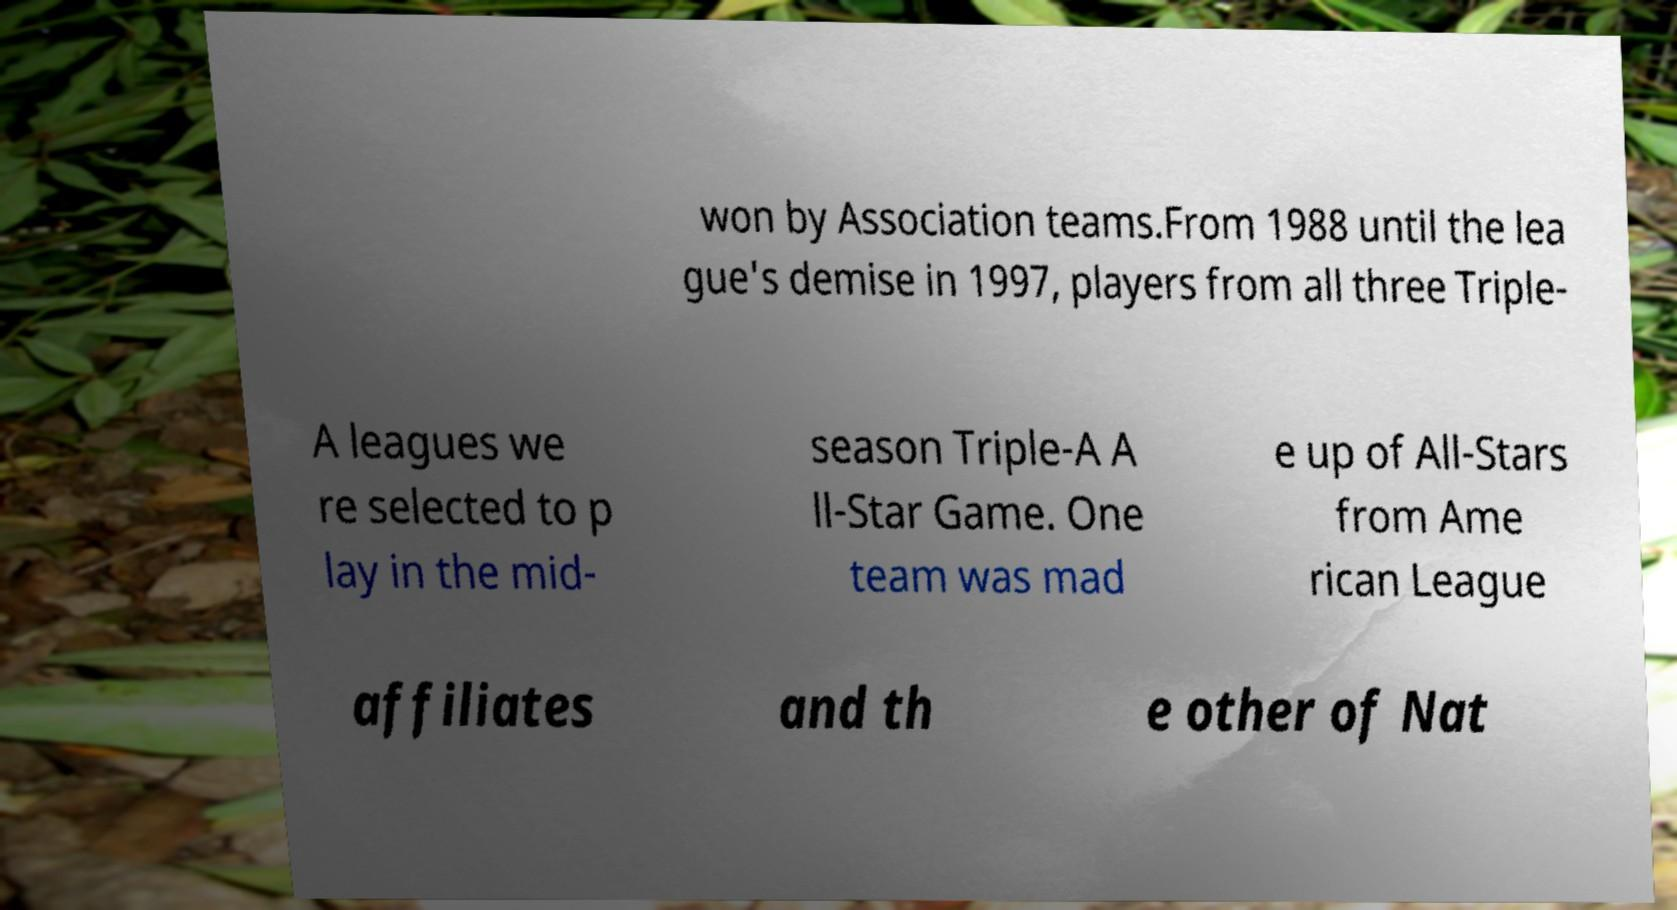Please identify and transcribe the text found in this image. won by Association teams.From 1988 until the lea gue's demise in 1997, players from all three Triple- A leagues we re selected to p lay in the mid- season Triple-A A ll-Star Game. One team was mad e up of All-Stars from Ame rican League affiliates and th e other of Nat 